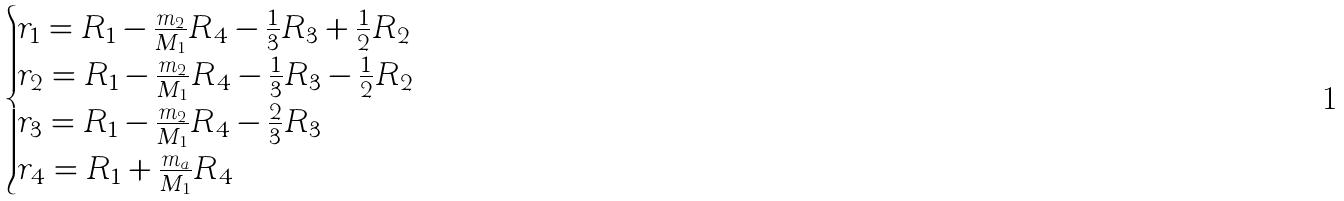Convert formula to latex. <formula><loc_0><loc_0><loc_500><loc_500>\begin{cases} r _ { 1 } = R _ { 1 } - \frac { m _ { 2 } } { M _ { 1 } } R _ { 4 } - \frac { 1 } { 3 } R _ { 3 } + \frac { 1 } { 2 } R _ { 2 } \\ r _ { 2 } = R _ { 1 } - \frac { m _ { 2 } } { M _ { 1 } } R _ { 4 } - \frac { 1 } { 3 } R _ { 3 } - \frac { 1 } { 2 } R _ { 2 } \\ r _ { 3 } = R _ { 1 } - \frac { m _ { 2 } } { M _ { 1 } } R _ { 4 } - \frac { 2 } { 3 } R _ { 3 } \\ r _ { 4 } = R _ { 1 } + \frac { m _ { a } } { M _ { 1 } } R _ { 4 } \end{cases}</formula> 